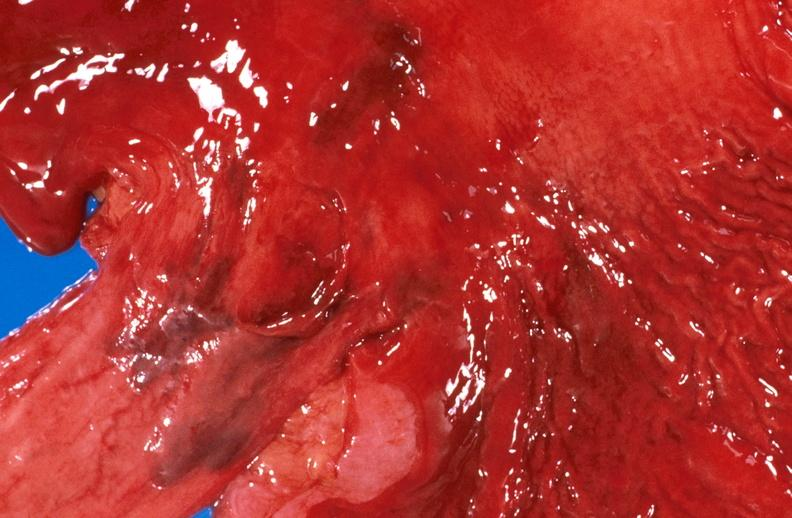s situs inversus present?
Answer the question using a single word or phrase. No 